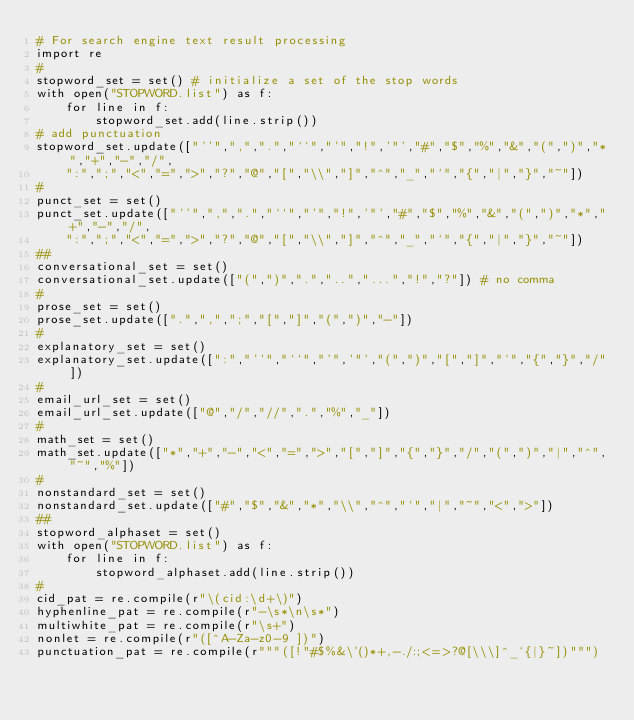Convert code to text. <code><loc_0><loc_0><loc_500><loc_500><_Python_># For search engine text result processing
import re
#
stopword_set = set() # initialize a set of the stop words
with open("STOPWORD.list") as f:
    for line in f:
        stopword_set.add(line.strip())
# add punctuation
stopword_set.update(["''",",",".","``","'","!",'"',"#","$","%","&","(",")","*","+","-","/",
    ":",";","<","=",">","?","@","[","\\","]","^","_","`","{","|","}","~"])
#
punct_set = set()
punct_set.update(["''",",",".","``","'","!",'"',"#","$","%","&","(",")","*","+","-","/",
    ":",";","<","=",">","?","@","[","\\","]","^","_","`","{","|","}","~"])
##
conversational_set = set()
conversational_set.update(["(",")",".","..","...","!","?"]) # no comma
#
prose_set = set()
prose_set.update([".",",",";","[","]","(",")","-"])
#
explanatory_set = set()
explanatory_set.update([":","''","``","'",'"',"(",")","[","]","`","{","}","/"])
#
email_url_set = set()
email_url_set.update(["@","/","//",".","%","_"])
#
math_set = set()
math_set.update(["*","+","-","<","=",">","[","]","{","}","/","(",")","|","^","~","%"])
#
nonstandard_set = set()
nonstandard_set.update(["#","$","&","*","\\","^","`","|","~","<",">"])
##
stopword_alphaset = set()
with open("STOPWORD.list") as f:
    for line in f:
        stopword_alphaset.add(line.strip())
#
cid_pat = re.compile(r"\(cid:\d+\)")
hyphenline_pat = re.compile(r"-\s*\n\s*")
multiwhite_pat = re.compile(r"\s+")
nonlet = re.compile(r"([^A-Za-z0-9 ])")
punctuation_pat = re.compile(r"""([!"#$%&\'()*+,-./:;<=>?@[\\\]^_`{|}~])""")
</code> 